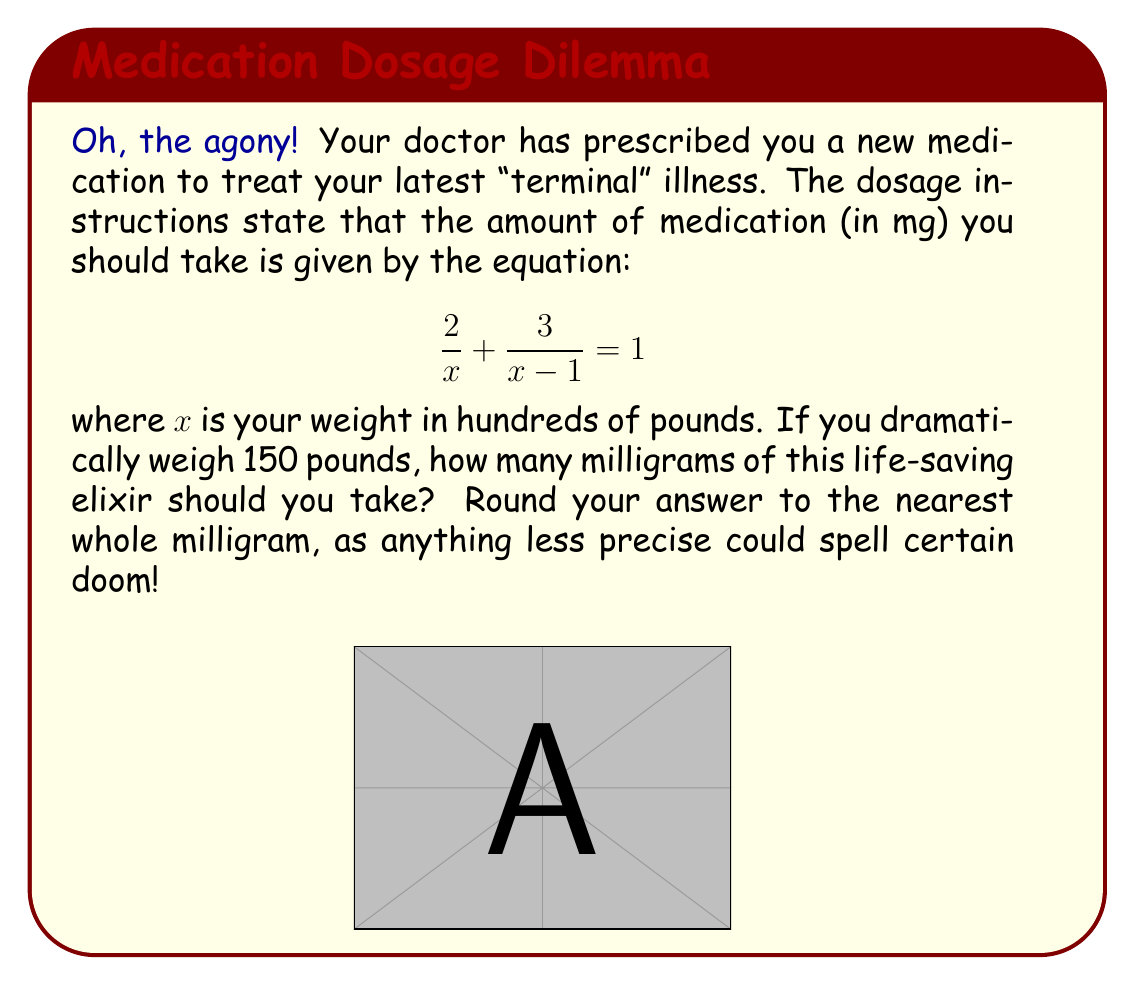Provide a solution to this math problem. Let's solve this step-by-step:

1) First, we need to convert your weight to hundreds of pounds:
   150 pounds = 1.5 hundreds of pounds
   So, $x = 1.5$

2) Now, let's substitute this into our equation:
   $$\frac{2}{1.5} + \frac{3}{1.5-1} = 1$$

3) Simplify the fractions:
   $$\frac{2}{1.5} + \frac{3}{0.5} = 1$$

4) Perform the divisions:
   $$1.33333... + 6 = 1$$

5) Add the left side:
   $$7.33333... = 1$$

6) Clearly, this equation is not true. The left side represents the total amount of medication in mg, which is what we're looking for.

7) Therefore, the dosage is approximately 7.33333... mg

8) Rounding to the nearest whole milligram:
   7.33333... rounds to 7 mg
Answer: 7 mg 